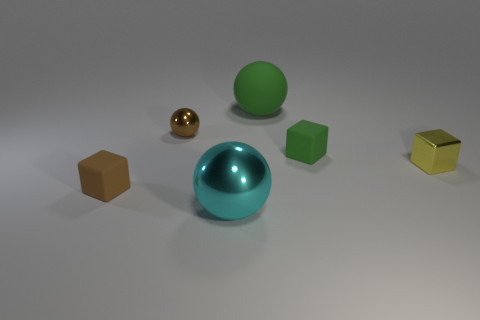Is there anything else that has the same size as the metal block?
Offer a very short reply. Yes. The thing that is the same color as the rubber ball is what size?
Make the answer very short. Small. Is there anything else that has the same material as the cyan ball?
Your answer should be very brief. Yes. What is the shape of the small yellow metal object?
Keep it short and to the point. Cube. The tiny brown object behind the small block that is left of the large green sphere is what shape?
Provide a short and direct response. Sphere. Are the block in front of the tiny yellow thing and the yellow thing made of the same material?
Offer a very short reply. No. What number of gray things are metallic spheres or rubber cylinders?
Provide a succinct answer. 0. Are there any small objects of the same color as the small metallic sphere?
Offer a very short reply. Yes. Are there any brown spheres that have the same material as the cyan thing?
Keep it short and to the point. Yes. The shiny object that is both left of the small yellow block and behind the brown matte cube has what shape?
Make the answer very short. Sphere. 